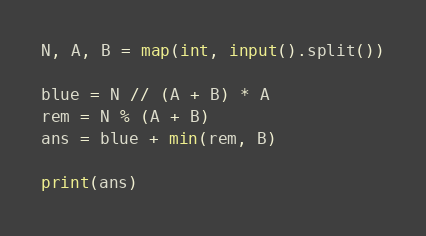<code> <loc_0><loc_0><loc_500><loc_500><_Python_>N, A, B = map(int, input().split())

blue = N // (A + B) * A
rem = N % (A + B)
ans = blue + min(rem, B)

print(ans)</code> 